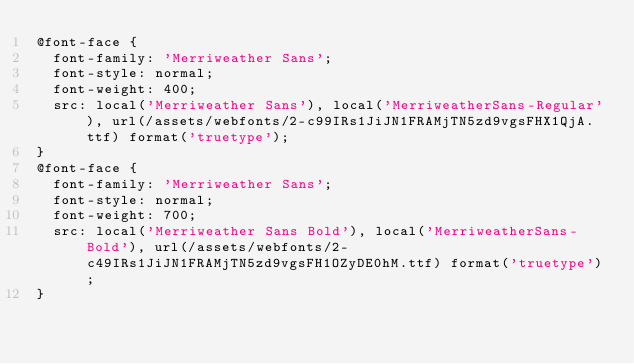<code> <loc_0><loc_0><loc_500><loc_500><_CSS_>@font-face {
  font-family: 'Merriweather Sans';
  font-style: normal;
  font-weight: 400;
  src: local('Merriweather Sans'), local('MerriweatherSans-Regular'), url(/assets/webfonts/2-c99IRs1JiJN1FRAMjTN5zd9vgsFHX1QjA.ttf) format('truetype');
}
@font-face {
  font-family: 'Merriweather Sans';
  font-style: normal;
  font-weight: 700;
  src: local('Merriweather Sans Bold'), local('MerriweatherSans-Bold'), url(/assets/webfonts/2-c49IRs1JiJN1FRAMjTN5zd9vgsFH1OZyDE0hM.ttf) format('truetype');
}
</code> 